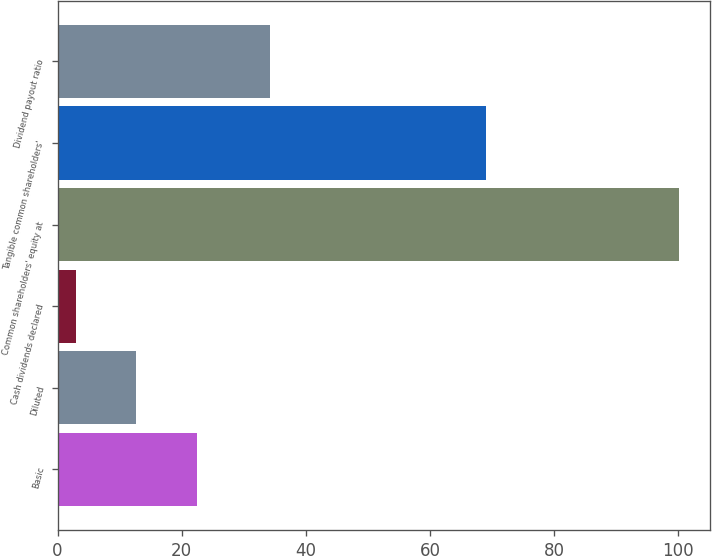Convert chart. <chart><loc_0><loc_0><loc_500><loc_500><bar_chart><fcel>Basic<fcel>Diluted<fcel>Cash dividends declared<fcel>Common shareholders' equity at<fcel>Tangible common shareholders'<fcel>Dividend payout ratio<nl><fcel>22.4<fcel>12.7<fcel>3<fcel>100.03<fcel>69.08<fcel>34.24<nl></chart> 